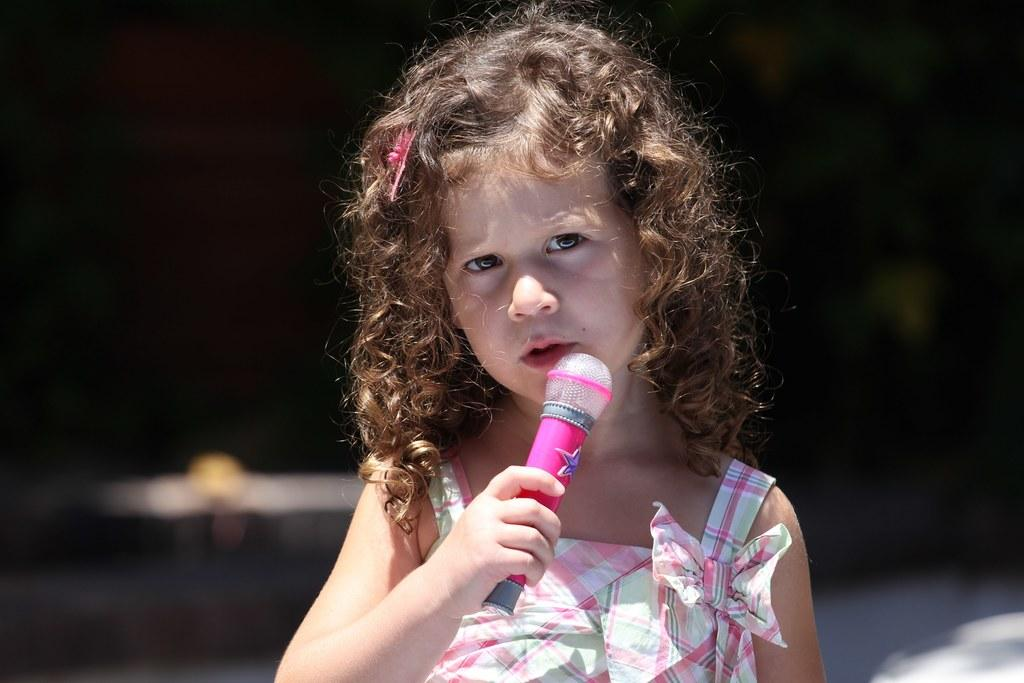What is the main subject of the image? There is a girl standing in the middle of the image. What is the girl holding in the image? The girl is holding a plastic microphone. What color is the plastic microphone? The plastic microphone is pink in color. What type of instrument is the girl playing in the image? The girl is not playing an instrument in the image; she is holding a plastic microphone. Can you see a wrench in the girl's hand in the image? No, there is no wrench present in the image; the girl is holding a pink plastic microphone. 